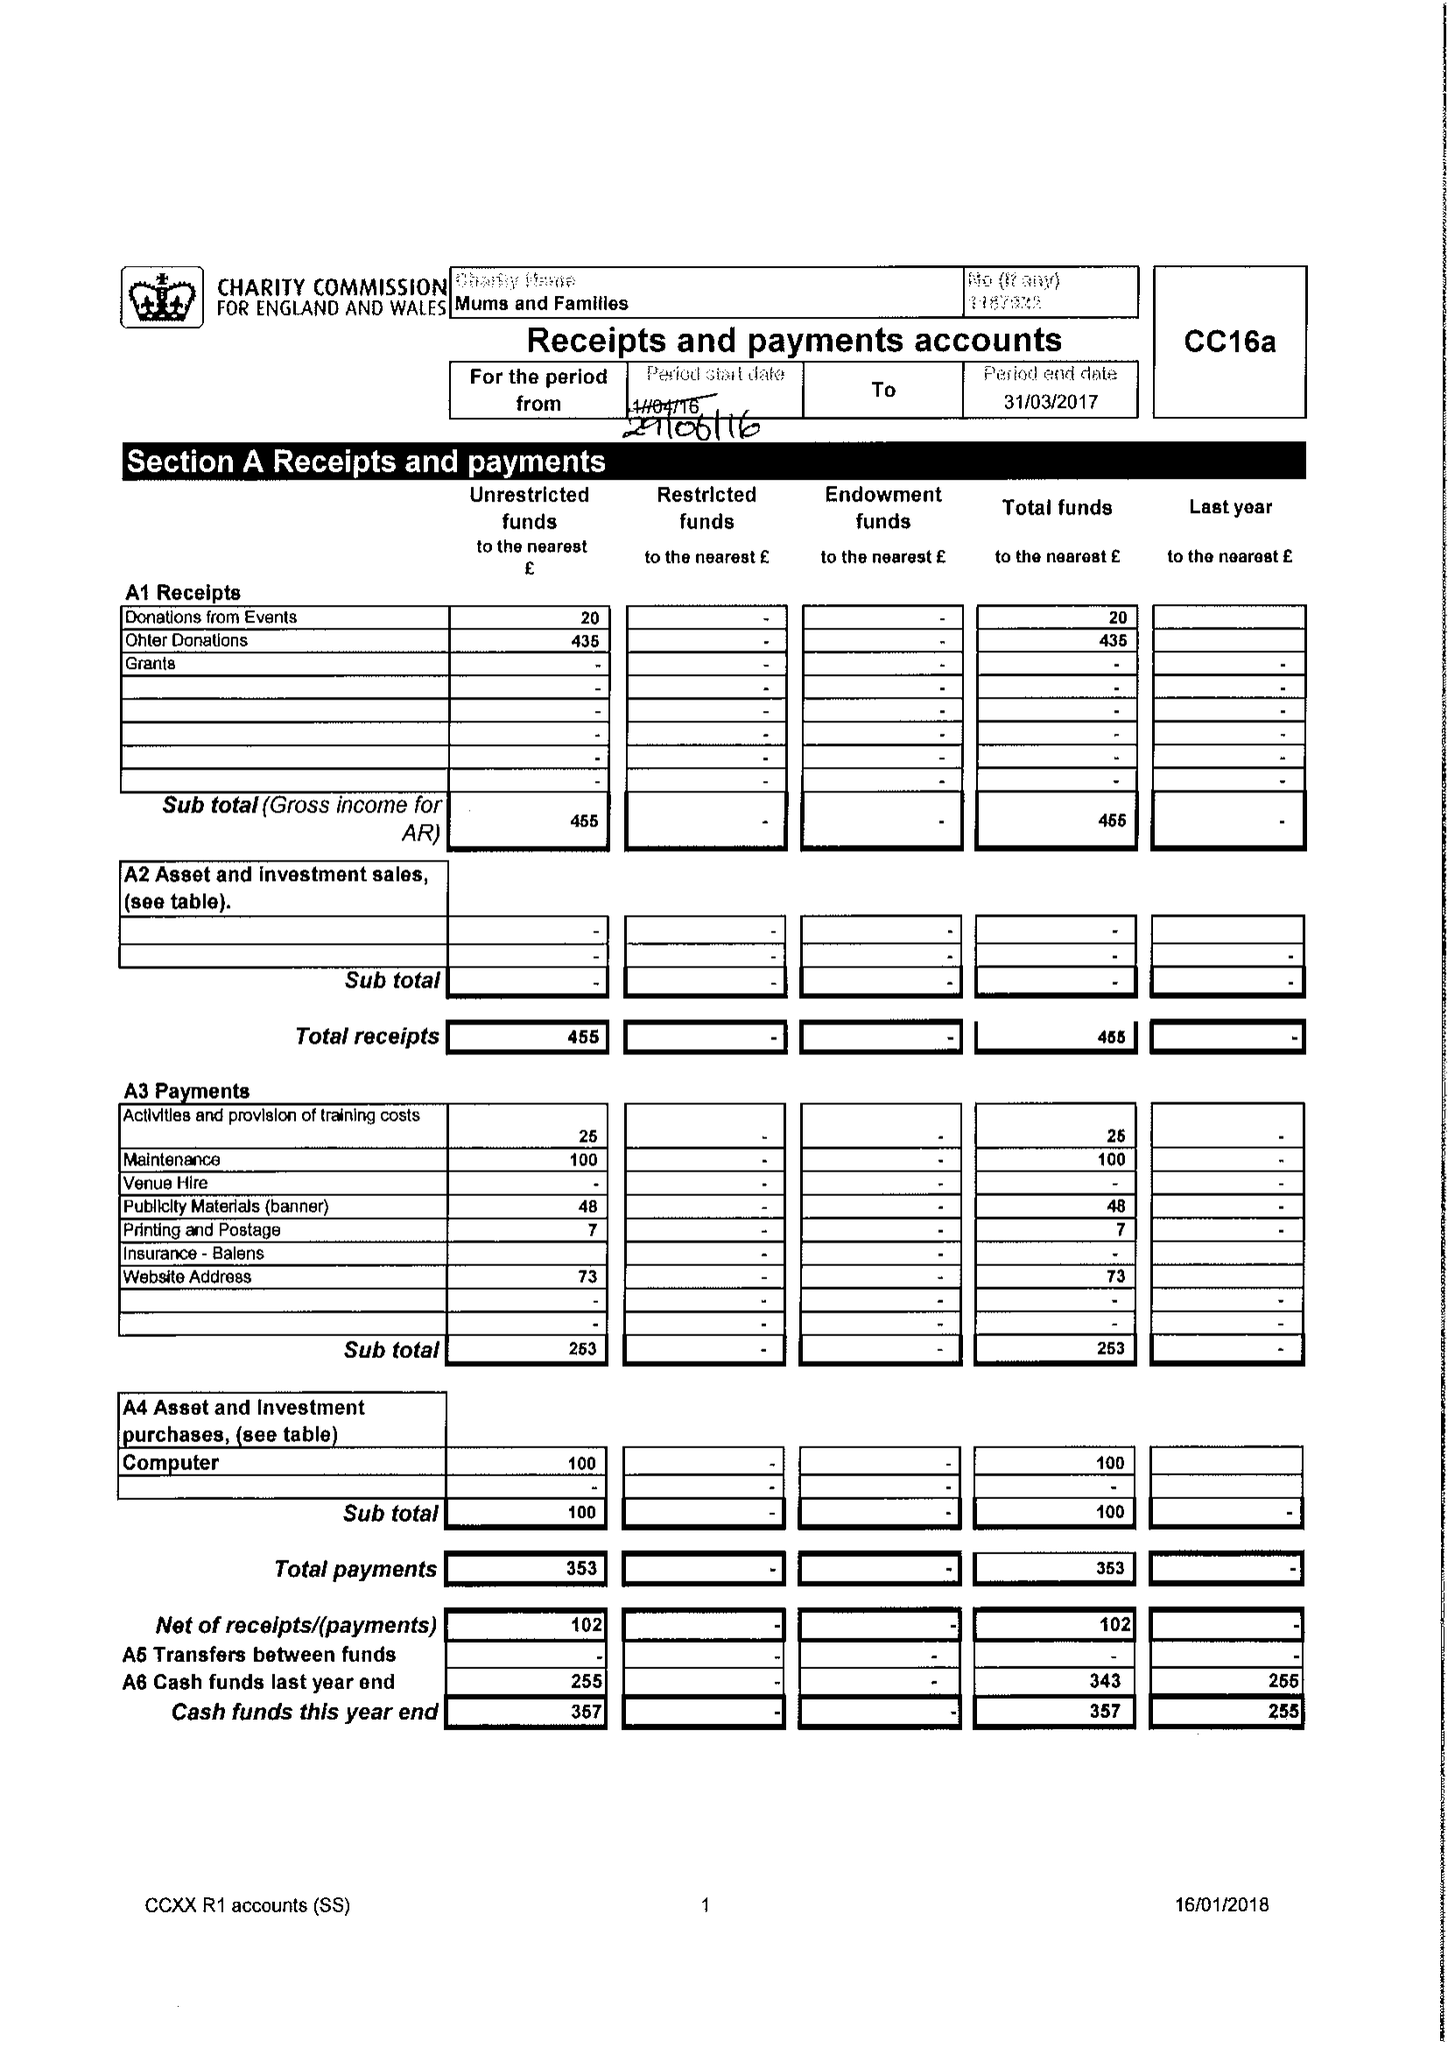What is the value for the income_annually_in_british_pounds?
Answer the question using a single word or phrase. 455.00 